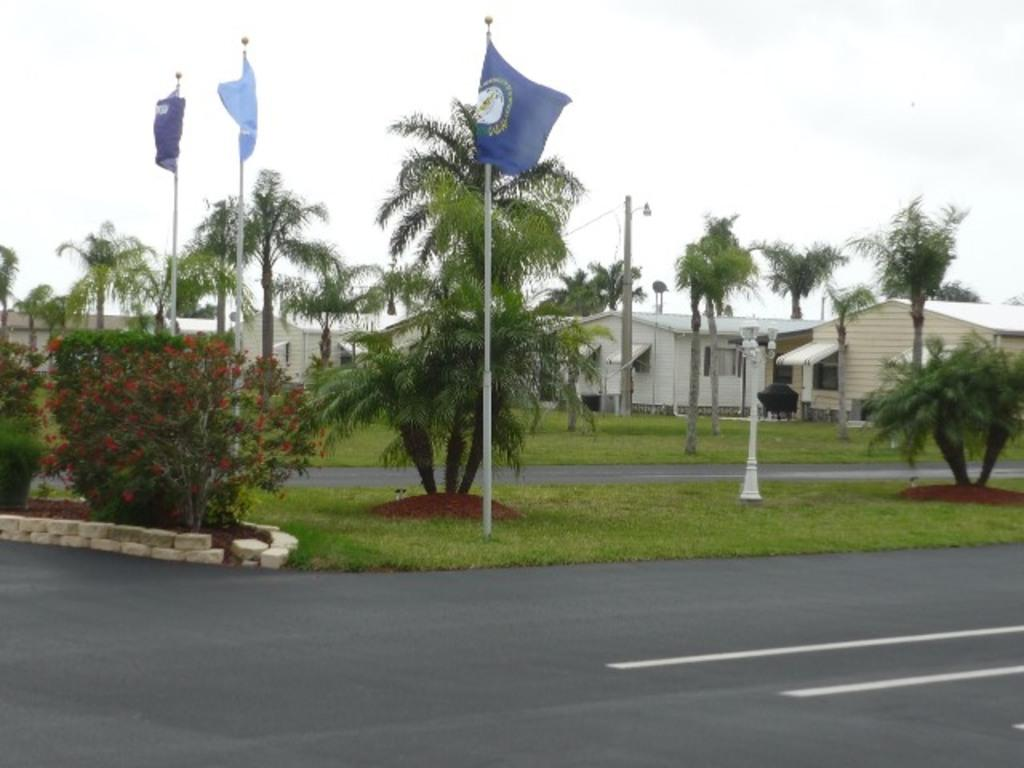What type of vegetation can be seen in the image? There is grass in the image. What else can be seen in the image besides grass? There are trees, houses, street lamps, and flags in the image. What is visible in the sky in the image? The sky is visible in the image. What is the rate at which the snails are moving in the image? There are no snails present in the image, so it is not possible to determine their rate of movement. 